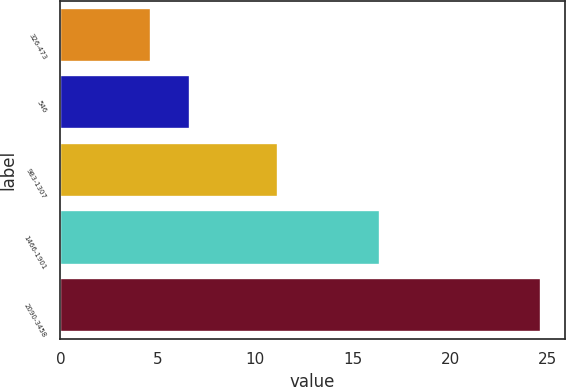Convert chart. <chart><loc_0><loc_0><loc_500><loc_500><bar_chart><fcel>326-473<fcel>546<fcel>983-1307<fcel>1466-1901<fcel>2090-3458<nl><fcel>4.64<fcel>6.64<fcel>11.17<fcel>16.38<fcel>24.63<nl></chart> 